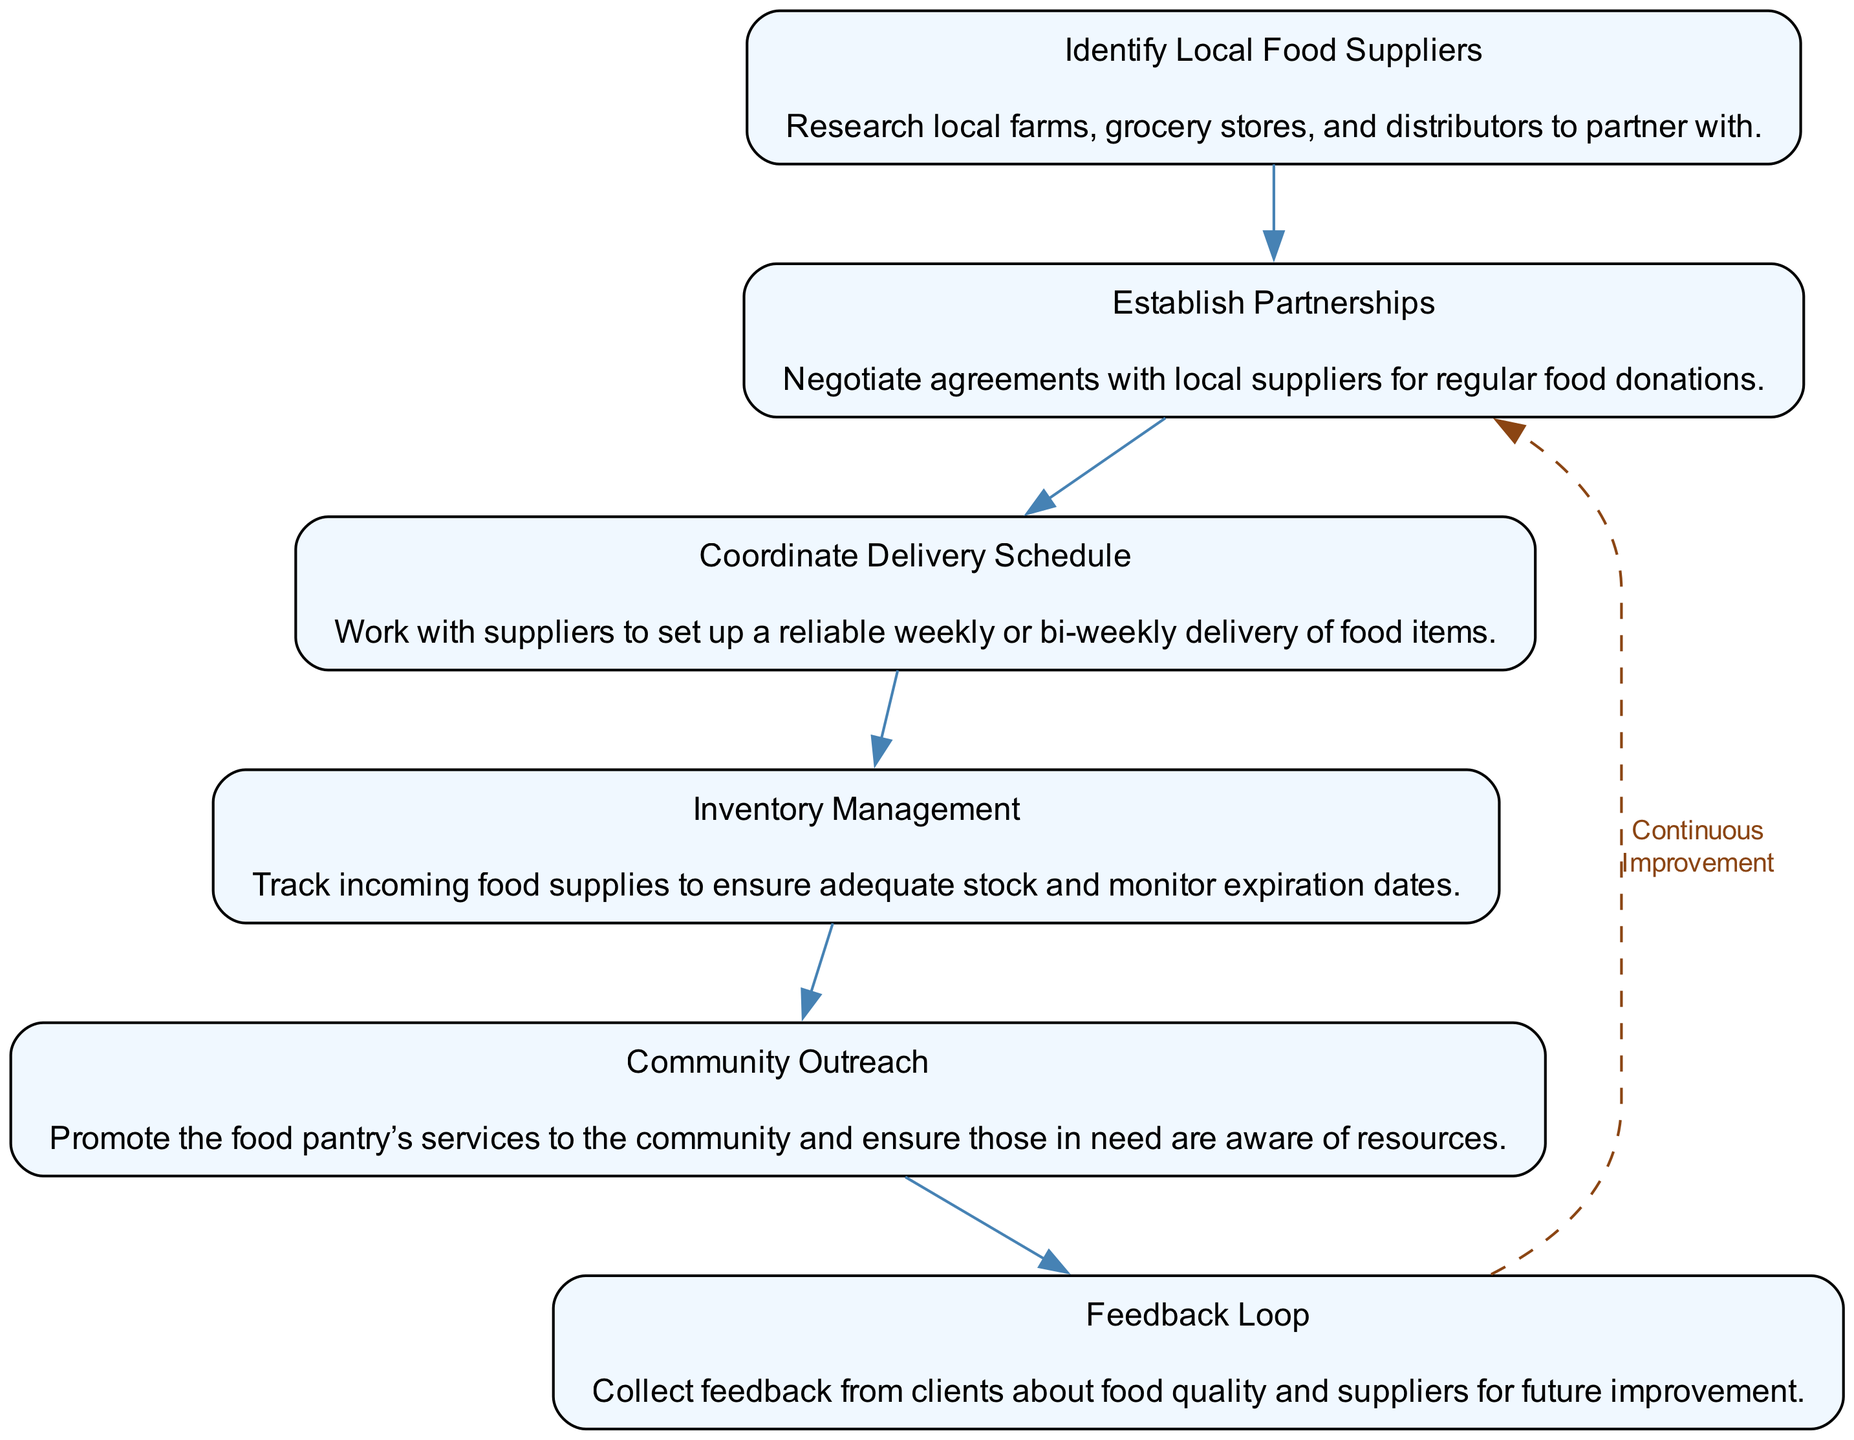What is the first step in the coordination process? The first step in the coordination process is the "Identify Local Food Suppliers" node, which is where the process begins. This node represents the action of researching local farms, grocery stores, and distributors to partner with.
Answer: Identify Local Food Suppliers How many nodes are there in the diagram? There are six nodes in the diagram, each representing a step in the coordination process. The nodes are sequentially connected to illustrate the flow of the process.
Answer: 6 What is the last step before the feedback loop? The last step before the feedback loop is "Community Outreach," which is crucial for promoting the food pantry's services and ensuring awareness among those in need.
Answer: Community Outreach What supplies must be managed after delivery? After deliveries, "Inventory Management" must take place to track incoming food supplies, ensuring adequate stock and monitoring expiration dates to prevent waste.
Answer: Inventory Management Which step involves negotiations with suppliers? The step that involves negotiations with suppliers is "Establish Partnerships," where agreements are arranged for regular food donations from local suppliers.
Answer: Establish Partnerships What is the relationship between "Feedback Loop" and "Establish Partnerships"? The relationship is one of continuous improvement; feedback collected from clients can inform future partnerships and adjustments to the supply chain, creating a dashed edge illustrating this loop.
Answer: Continuous Improvement 